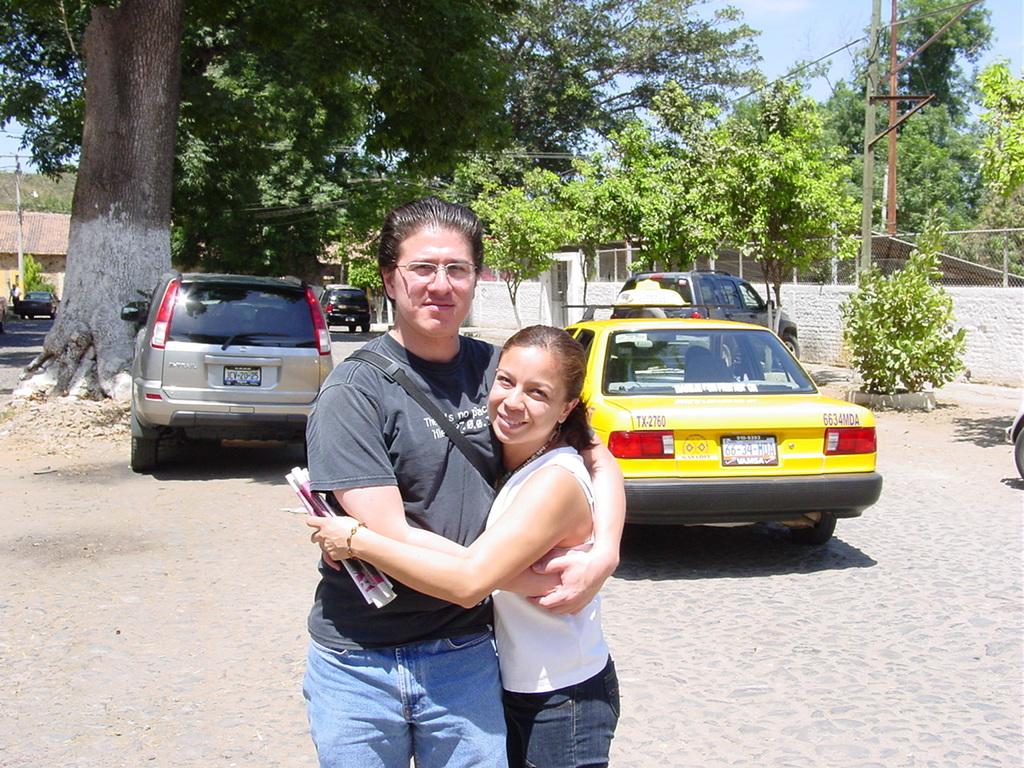Is that taxi, tx-2760?
Ensure brevity in your answer.  Yes. What is the sex of the people in the picture?
Your answer should be compact. Answering does not require reading text in the image. 